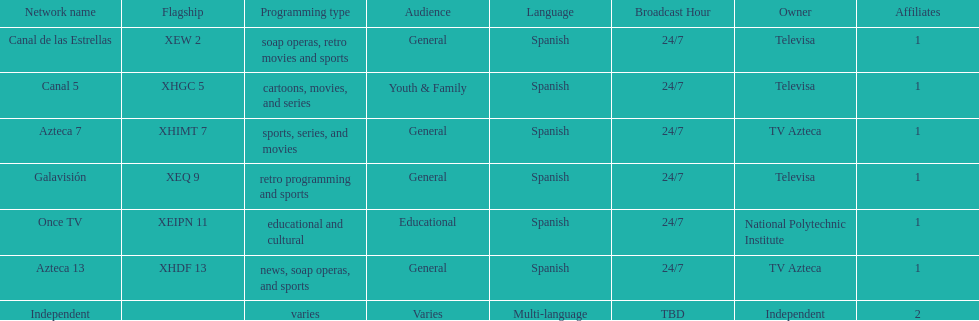What is the total number of affiliates among all the networks? 8. 